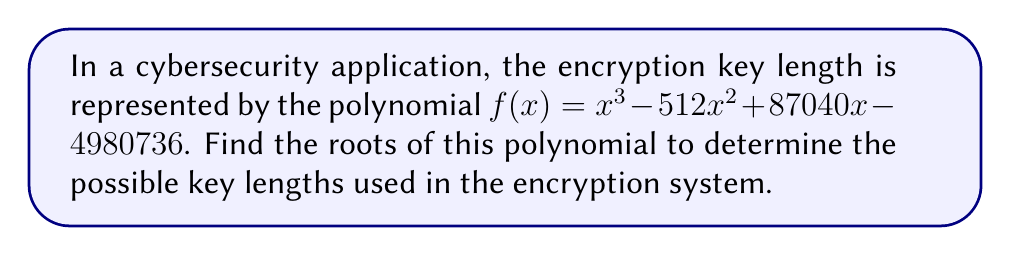Help me with this question. To find the roots of the polynomial $f(x) = x^3 - 512x^2 + 87040x - 4980736$, we need to factor it. Let's approach this step-by-step:

1) First, let's check if there are any rational roots using the rational root theorem. The possible rational roots are the factors of the constant term: $\pm 1, \pm 2, \pm 3, \pm 4, \pm 6, \pm 8, \pm 12, \pm 16, \pm 24, \pm 32, \pm 48, \pm 64, \pm 96, \pm 128, \pm 192, \pm 256$.

2) Testing these values, we find that 256 is a root of the polynomial.

3) Now we can factor out $(x - 256)$:

   $f(x) = (x - 256)(x^2 - 256x + 19456)$

4) The quadratic factor $x^2 - 256x + 19456$ can be solved using the quadratic formula:

   $x = \frac{-b \pm \sqrt{b^2 - 4ac}}{2a}$

   Where $a = 1$, $b = -256$, and $c = 19456$

5) Substituting these values:

   $x = \frac{256 \pm \sqrt{256^2 - 4(1)(19456)}}{2(1)}$

   $= \frac{256 \pm \sqrt{65536 - 77824}}{2}$

   $= \frac{256 \pm \sqrt{-12288}}{2}$

   $= \frac{256 \pm 112i}{2}$

6) Simplifying:

   $x = 128 \pm 56i$

Therefore, the roots of the polynomial are 256, $128 + 56i$, and $128 - 56i$.
Answer: The roots of the polynomial are: 256, $128 + 56i$, and $128 - 56i$. 